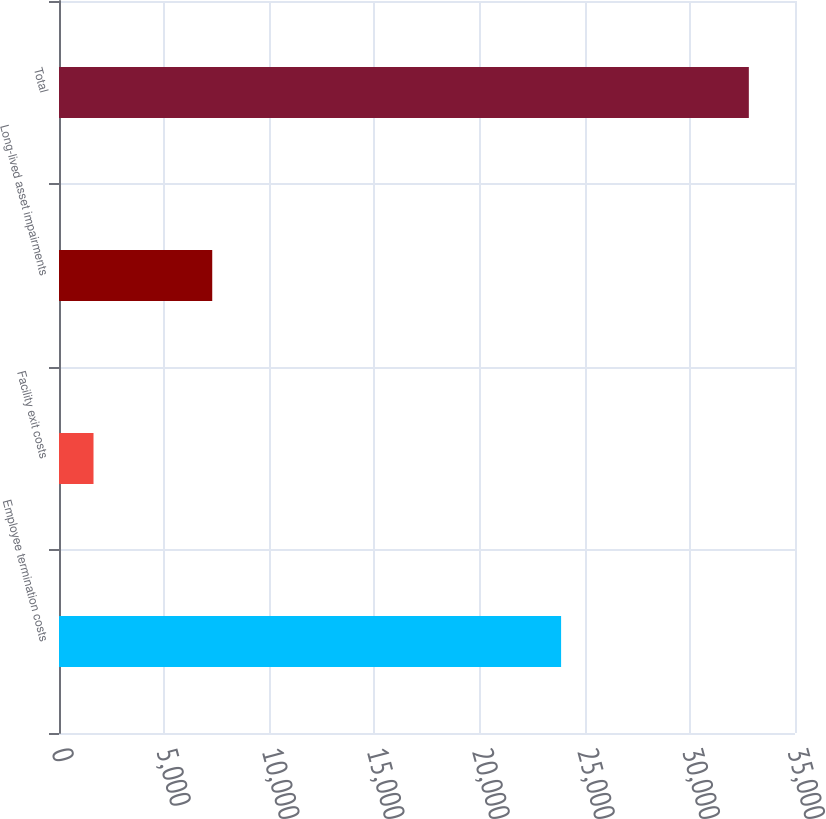<chart> <loc_0><loc_0><loc_500><loc_500><bar_chart><fcel>Employee termination costs<fcel>Facility exit costs<fcel>Long-lived asset impairments<fcel>Total<nl><fcel>23877<fcel>1641<fcel>7287<fcel>32805<nl></chart> 